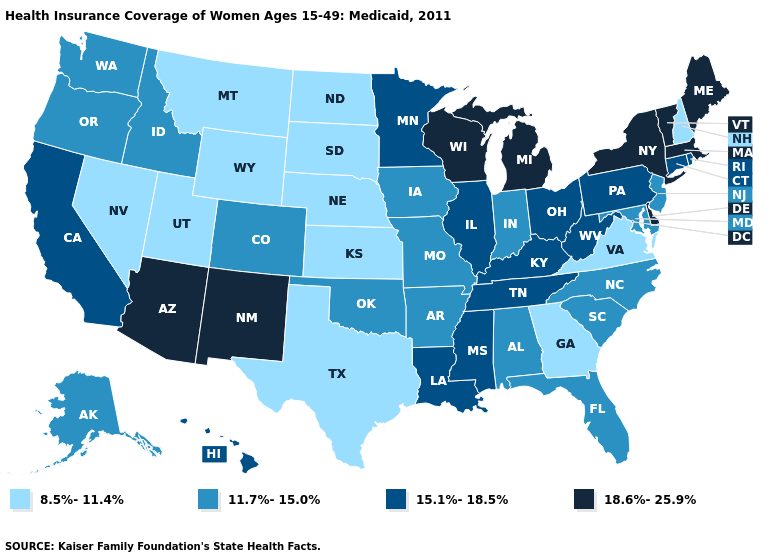Which states have the lowest value in the USA?
Concise answer only. Georgia, Kansas, Montana, Nebraska, Nevada, New Hampshire, North Dakota, South Dakota, Texas, Utah, Virginia, Wyoming. Does Montana have the lowest value in the West?
Write a very short answer. Yes. Name the states that have a value in the range 8.5%-11.4%?
Keep it brief. Georgia, Kansas, Montana, Nebraska, Nevada, New Hampshire, North Dakota, South Dakota, Texas, Utah, Virginia, Wyoming. Name the states that have a value in the range 18.6%-25.9%?
Keep it brief. Arizona, Delaware, Maine, Massachusetts, Michigan, New Mexico, New York, Vermont, Wisconsin. Does Delaware have the highest value in the South?
Give a very brief answer. Yes. Name the states that have a value in the range 11.7%-15.0%?
Concise answer only. Alabama, Alaska, Arkansas, Colorado, Florida, Idaho, Indiana, Iowa, Maryland, Missouri, New Jersey, North Carolina, Oklahoma, Oregon, South Carolina, Washington. Name the states that have a value in the range 11.7%-15.0%?
Short answer required. Alabama, Alaska, Arkansas, Colorado, Florida, Idaho, Indiana, Iowa, Maryland, Missouri, New Jersey, North Carolina, Oklahoma, Oregon, South Carolina, Washington. What is the value of Arizona?
Write a very short answer. 18.6%-25.9%. What is the lowest value in the MidWest?
Concise answer only. 8.5%-11.4%. Among the states that border Arkansas , which have the lowest value?
Be succinct. Texas. Name the states that have a value in the range 15.1%-18.5%?
Short answer required. California, Connecticut, Hawaii, Illinois, Kentucky, Louisiana, Minnesota, Mississippi, Ohio, Pennsylvania, Rhode Island, Tennessee, West Virginia. Does the map have missing data?
Concise answer only. No. Does the first symbol in the legend represent the smallest category?
Concise answer only. Yes. What is the value of North Carolina?
Give a very brief answer. 11.7%-15.0%. What is the highest value in states that border Texas?
Concise answer only. 18.6%-25.9%. 